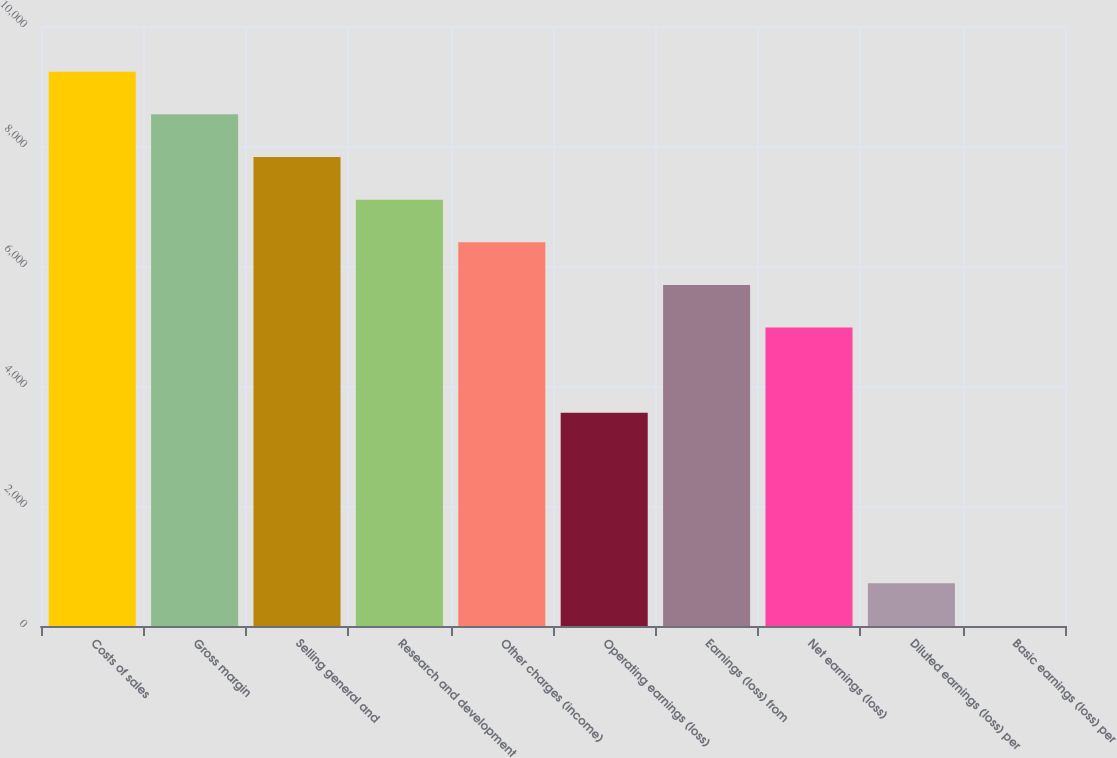Convert chart. <chart><loc_0><loc_0><loc_500><loc_500><bar_chart><fcel>Costs of sales<fcel>Gross margin<fcel>Selling general and<fcel>Research and development<fcel>Other charges (income)<fcel>Operating earnings (loss)<fcel>Earnings (loss) from<fcel>Net earnings (loss)<fcel>Diluted earnings (loss) per<fcel>Basic earnings (loss) per<nl><fcel>9237.84<fcel>8527.24<fcel>7816.64<fcel>7106.04<fcel>6395.44<fcel>3553.04<fcel>5684.84<fcel>4974.24<fcel>710.64<fcel>0.04<nl></chart> 